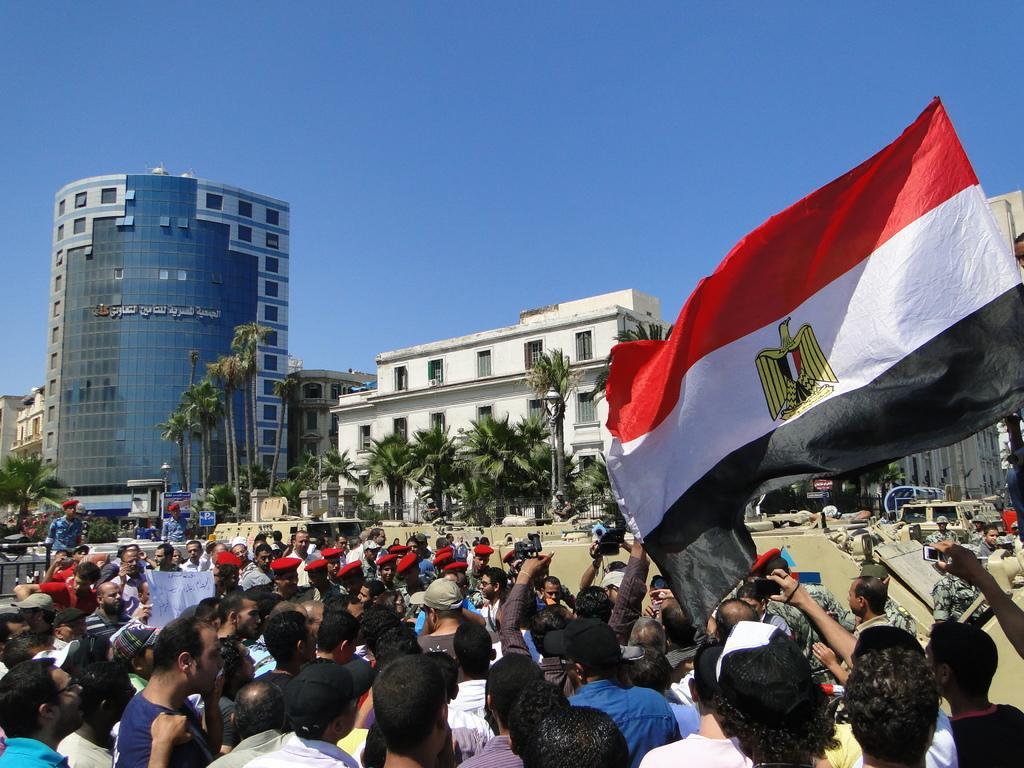In one or two sentences, can you explain what this image depicts? In this image I can see people protesting. There is a flagon the right. There are trees and buildings at the back. 